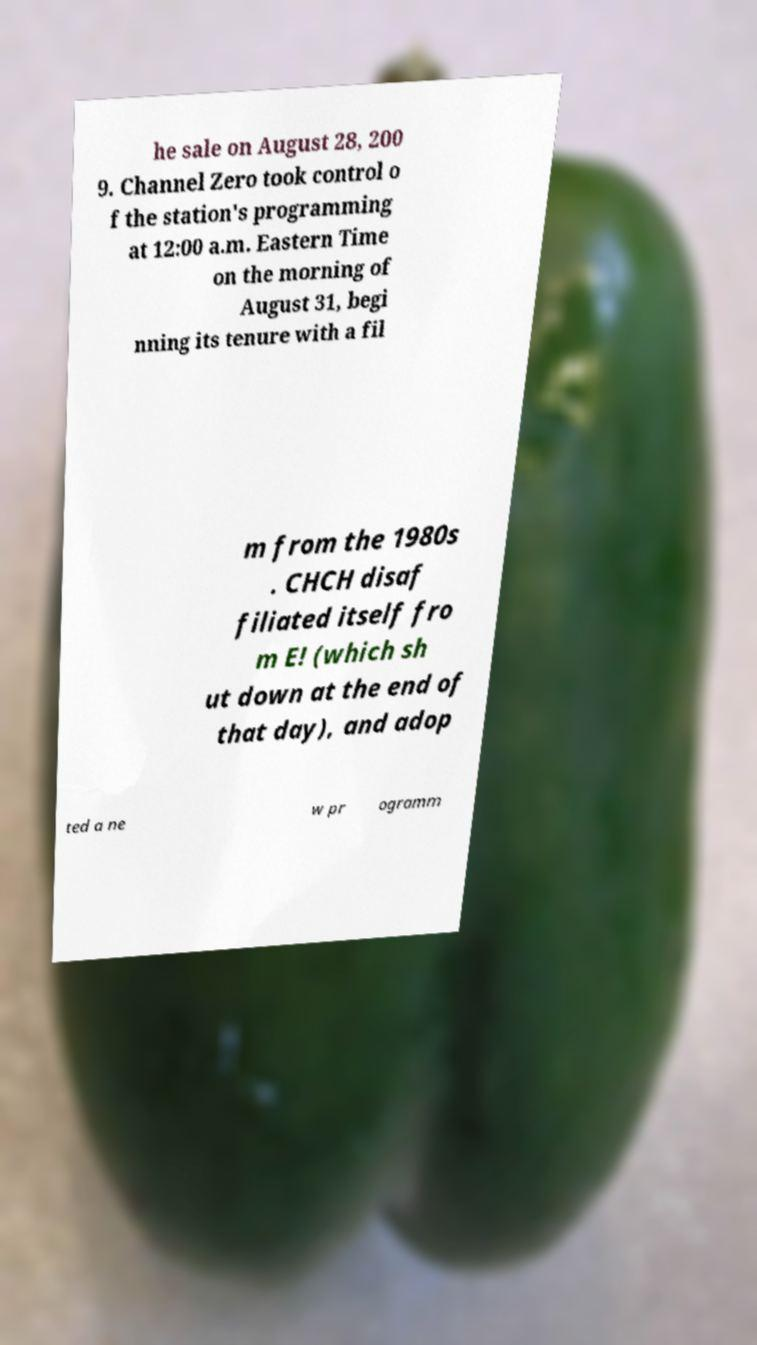I need the written content from this picture converted into text. Can you do that? he sale on August 28, 200 9. Channel Zero took control o f the station's programming at 12:00 a.m. Eastern Time on the morning of August 31, begi nning its tenure with a fil m from the 1980s . CHCH disaf filiated itself fro m E! (which sh ut down at the end of that day), and adop ted a ne w pr ogramm 